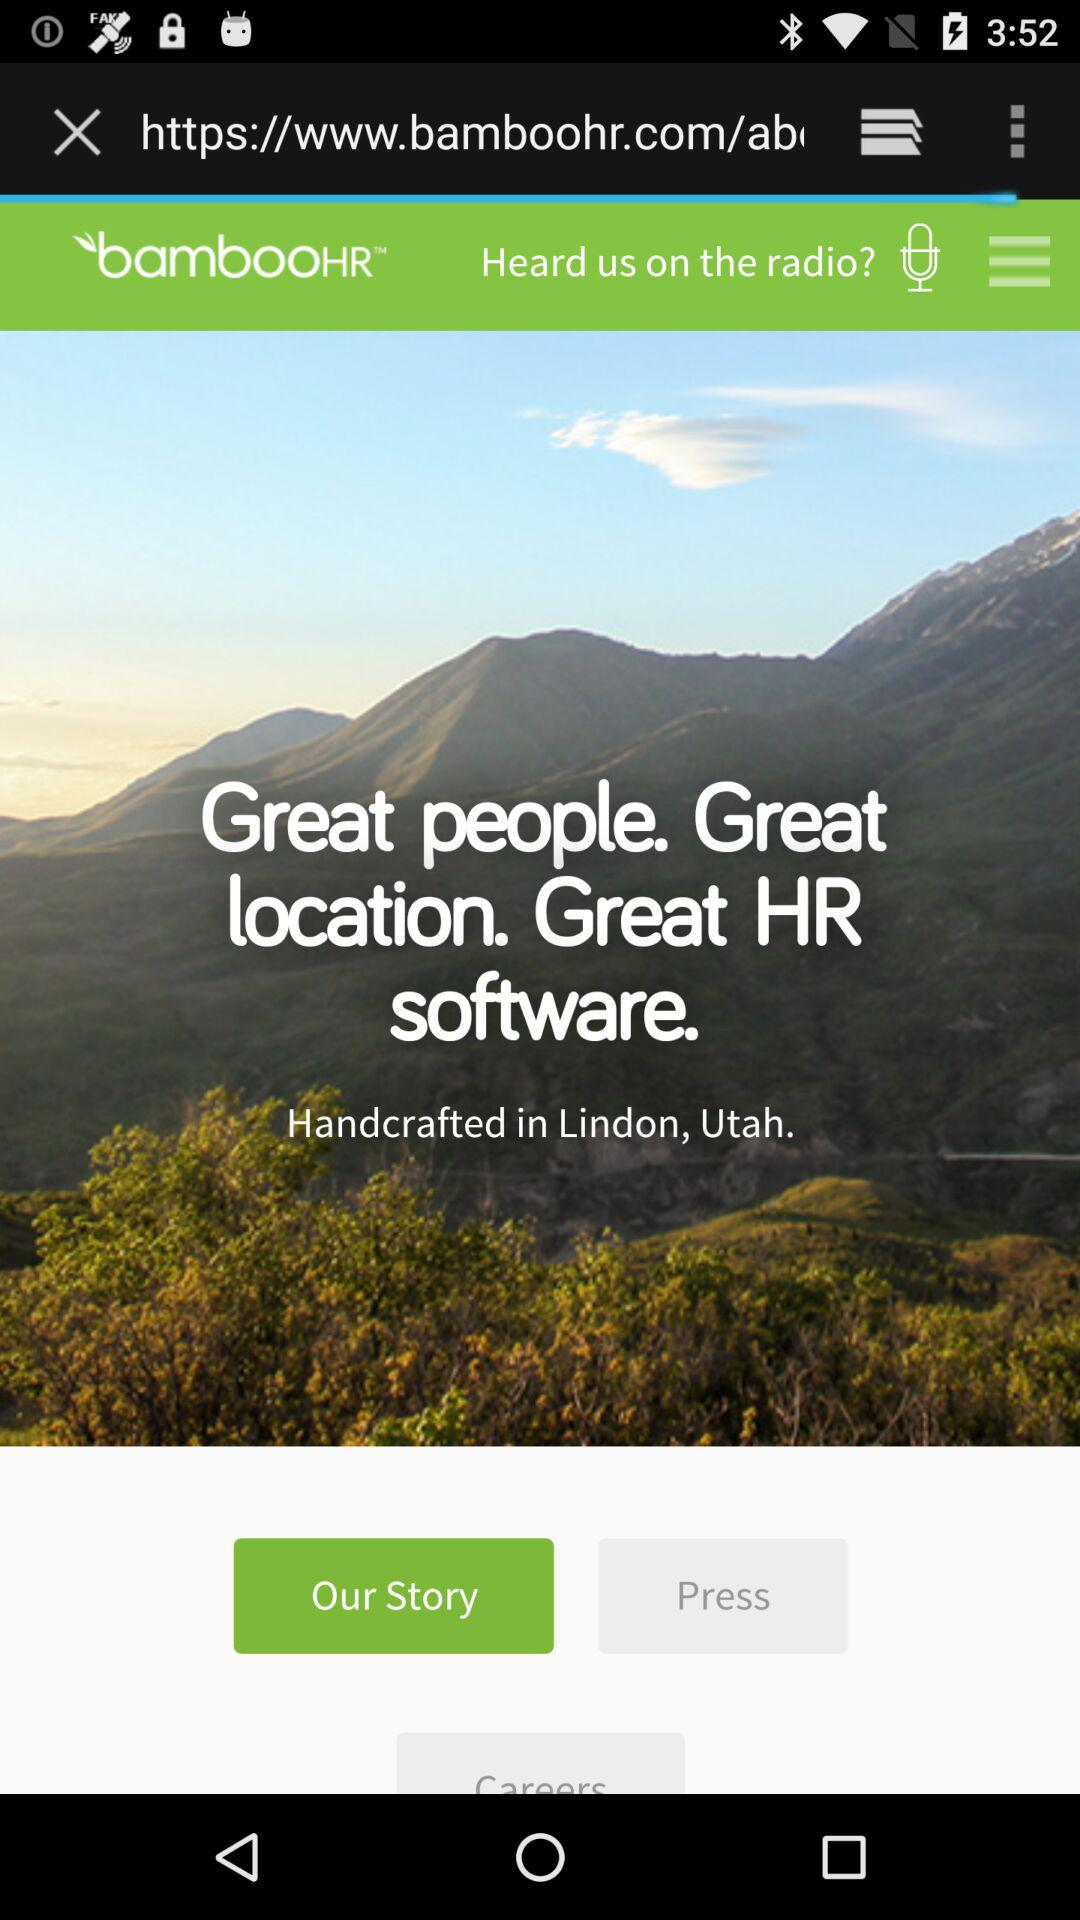What is the name of the application? The name of the application is "bambooHR". 